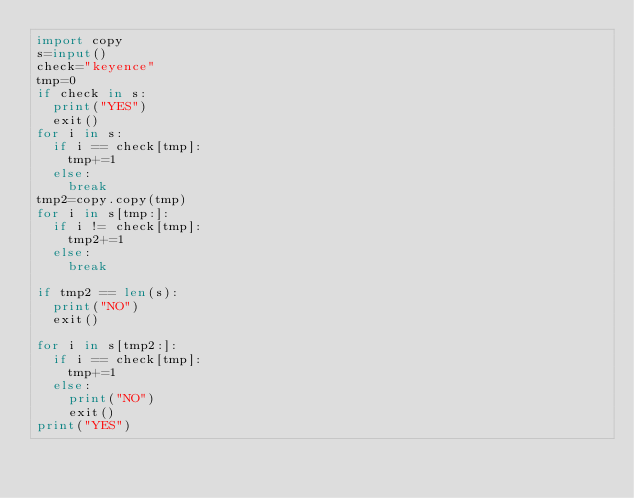Convert code to text. <code><loc_0><loc_0><loc_500><loc_500><_Python_>import copy
s=input()
check="keyence"
tmp=0
if check in s:
  print("YES")
  exit()
for i in s:
  if i == check[tmp]:
    tmp+=1
  else:
    break
tmp2=copy.copy(tmp)
for i in s[tmp:]:
  if i != check[tmp]:
    tmp2+=1
  else:
    break

if tmp2 == len(s):
  print("NO")
  exit()

for i in s[tmp2:]:
  if i == check[tmp]:
    tmp+=1
  else:
    print("NO")
    exit()
print("YES")</code> 